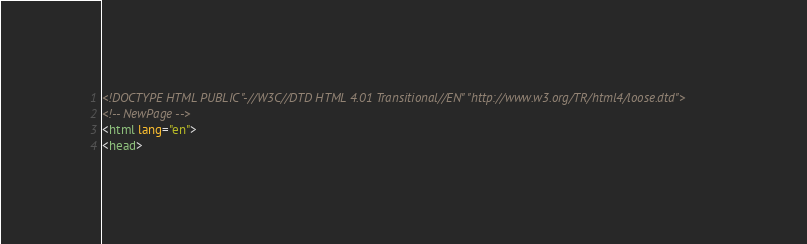Convert code to text. <code><loc_0><loc_0><loc_500><loc_500><_HTML_><!DOCTYPE HTML PUBLIC "-//W3C//DTD HTML 4.01 Transitional//EN" "http://www.w3.org/TR/html4/loose.dtd">
<!-- NewPage -->
<html lang="en">
<head></code> 